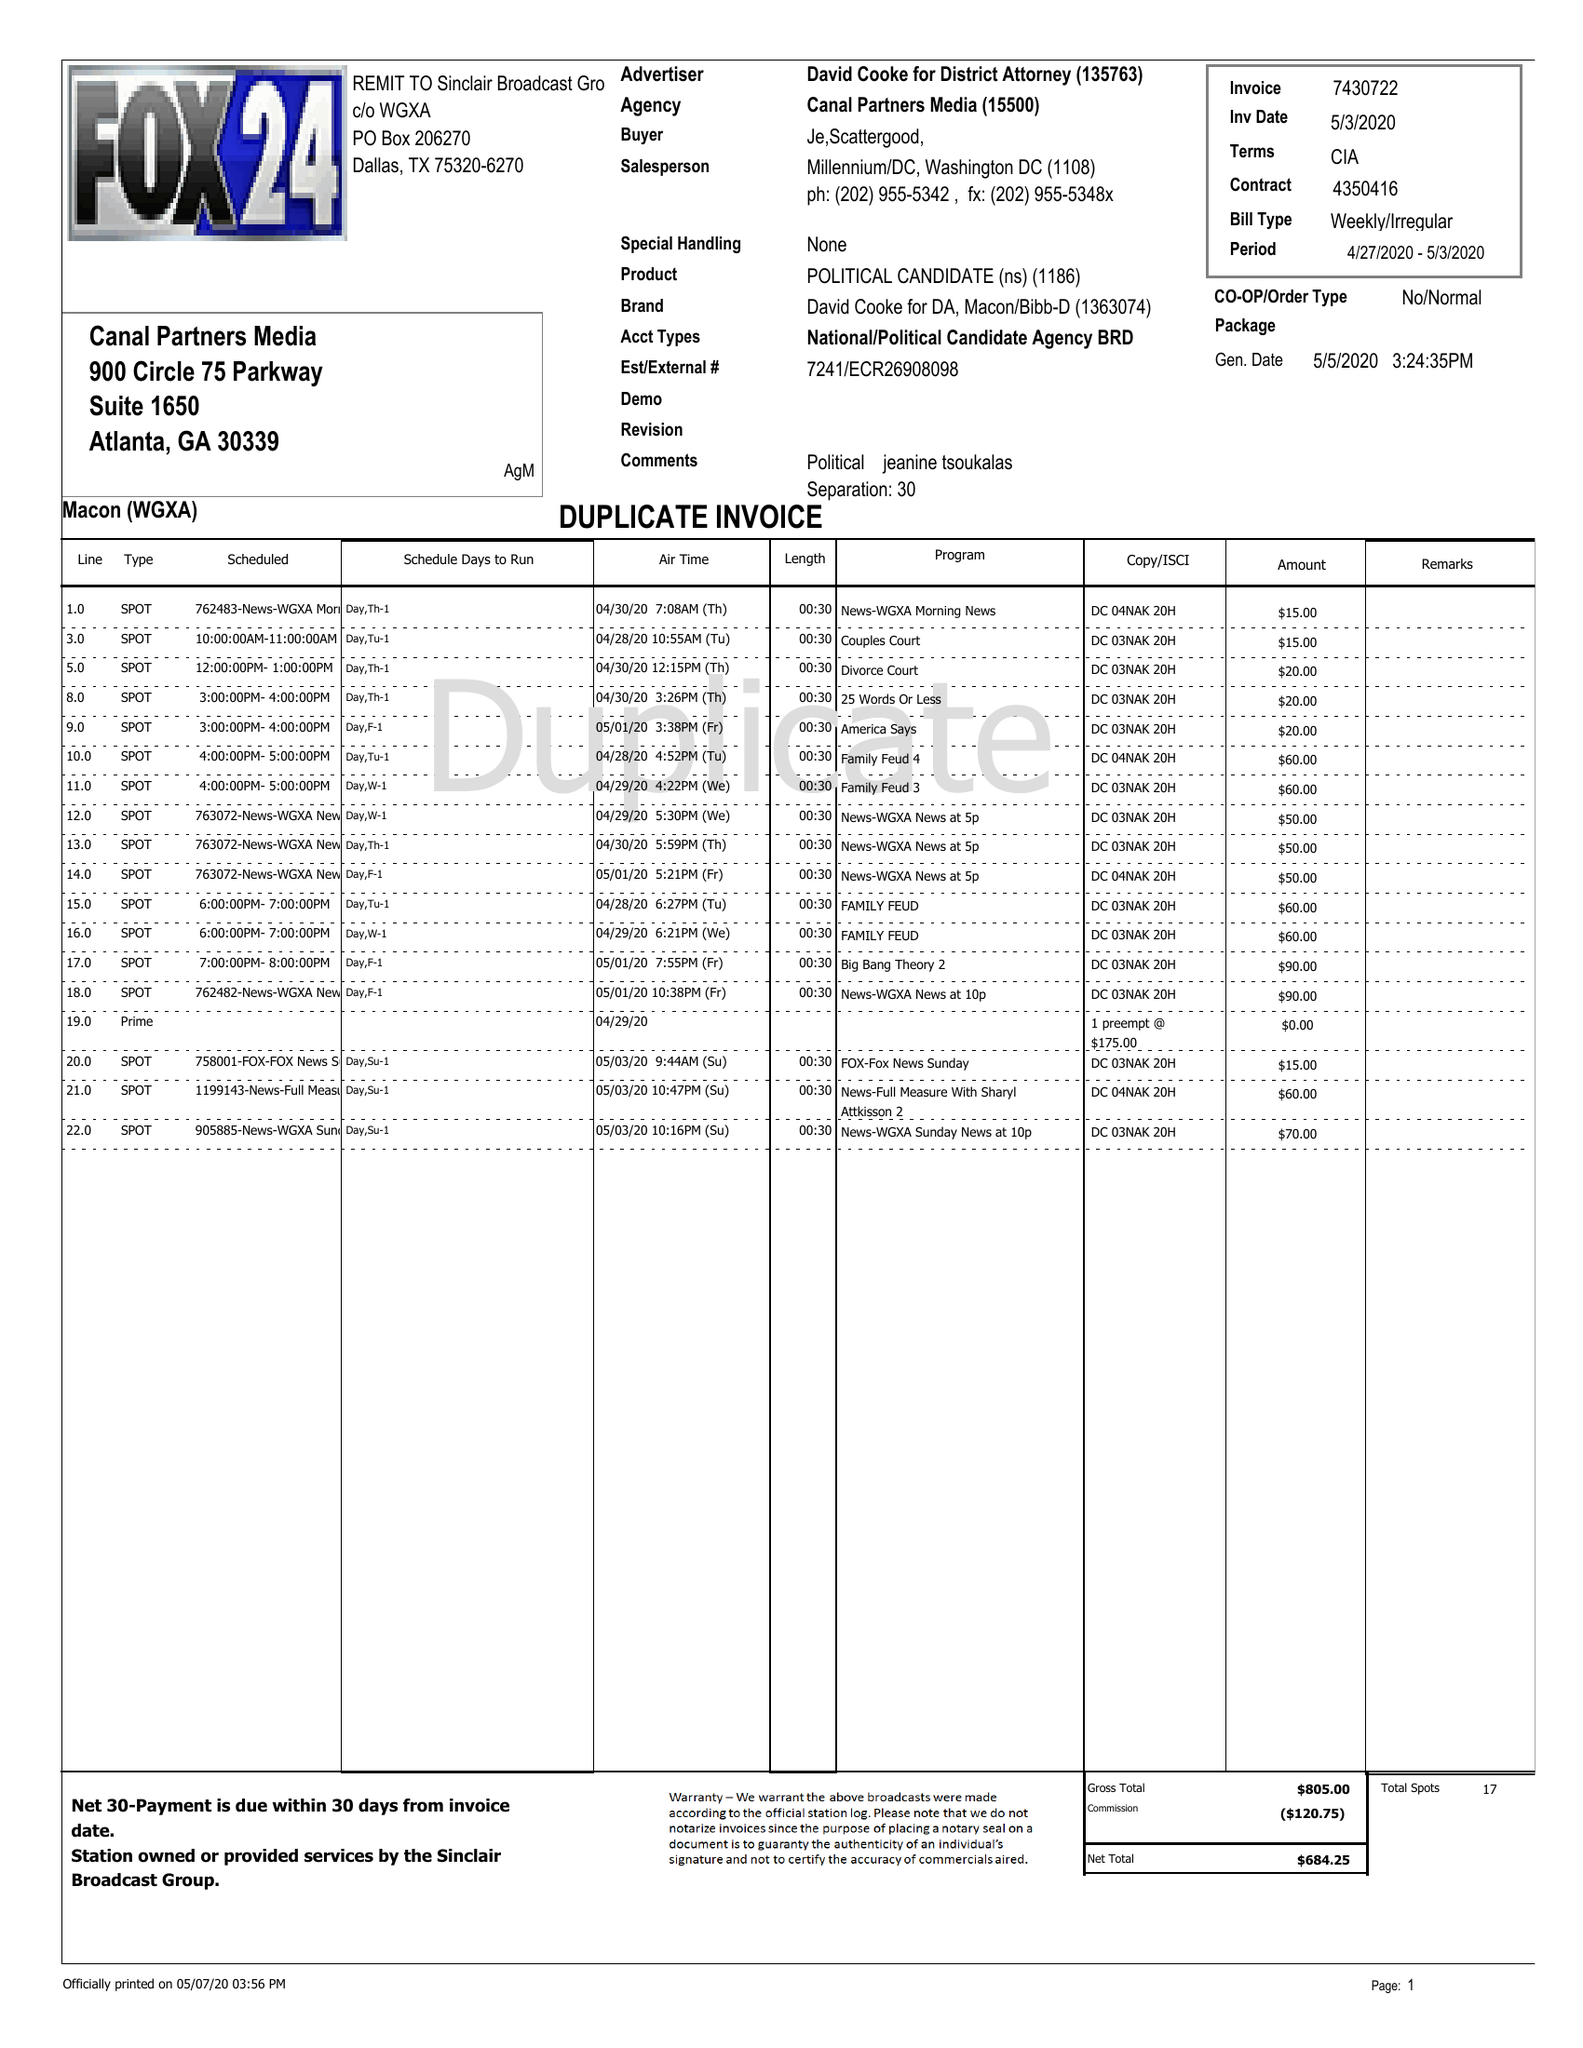What is the value for the gross_amount?
Answer the question using a single word or phrase. 805.00 